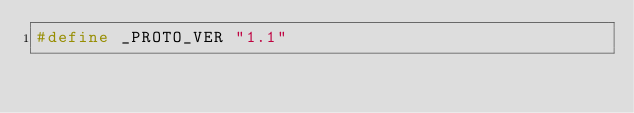Convert code to text. <code><loc_0><loc_0><loc_500><loc_500><_C_>#define _PROTO_VER "1.1"
</code> 